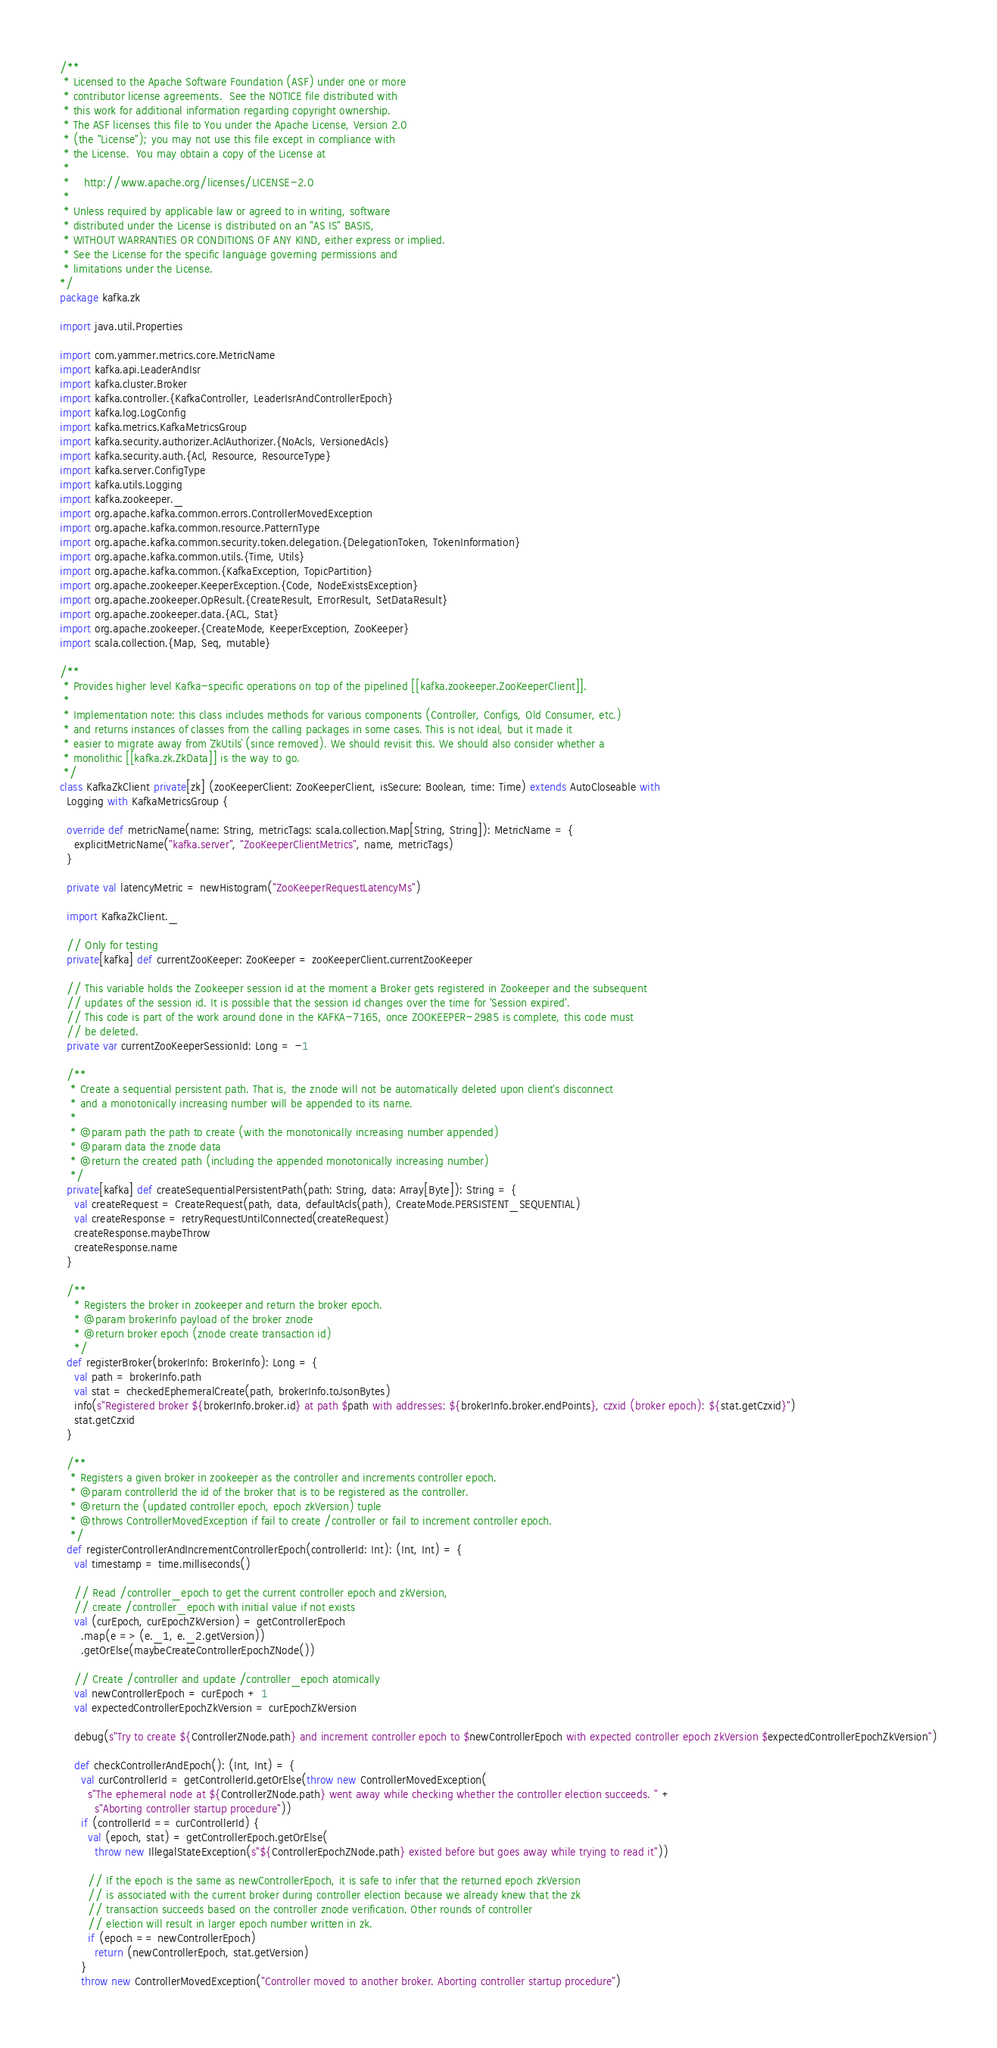Convert code to text. <code><loc_0><loc_0><loc_500><loc_500><_Scala_>/**
 * Licensed to the Apache Software Foundation (ASF) under one or more
 * contributor license agreements.  See the NOTICE file distributed with
 * this work for additional information regarding copyright ownership.
 * The ASF licenses this file to You under the Apache License, Version 2.0
 * (the "License"); you may not use this file except in compliance with
 * the License.  You may obtain a copy of the License at
 *
 *    http://www.apache.org/licenses/LICENSE-2.0
 *
 * Unless required by applicable law or agreed to in writing, software
 * distributed under the License is distributed on an "AS IS" BASIS,
 * WITHOUT WARRANTIES OR CONDITIONS OF ANY KIND, either express or implied.
 * See the License for the specific language governing permissions and
 * limitations under the License.
*/
package kafka.zk

import java.util.Properties

import com.yammer.metrics.core.MetricName
import kafka.api.LeaderAndIsr
import kafka.cluster.Broker
import kafka.controller.{KafkaController, LeaderIsrAndControllerEpoch}
import kafka.log.LogConfig
import kafka.metrics.KafkaMetricsGroup
import kafka.security.authorizer.AclAuthorizer.{NoAcls, VersionedAcls}
import kafka.security.auth.{Acl, Resource, ResourceType}
import kafka.server.ConfigType
import kafka.utils.Logging
import kafka.zookeeper._
import org.apache.kafka.common.errors.ControllerMovedException
import org.apache.kafka.common.resource.PatternType
import org.apache.kafka.common.security.token.delegation.{DelegationToken, TokenInformation}
import org.apache.kafka.common.utils.{Time, Utils}
import org.apache.kafka.common.{KafkaException, TopicPartition}
import org.apache.zookeeper.KeeperException.{Code, NodeExistsException}
import org.apache.zookeeper.OpResult.{CreateResult, ErrorResult, SetDataResult}
import org.apache.zookeeper.data.{ACL, Stat}
import org.apache.zookeeper.{CreateMode, KeeperException, ZooKeeper}
import scala.collection.{Map, Seq, mutable}

/**
 * Provides higher level Kafka-specific operations on top of the pipelined [[kafka.zookeeper.ZooKeeperClient]].
 *
 * Implementation note: this class includes methods for various components (Controller, Configs, Old Consumer, etc.)
 * and returns instances of classes from the calling packages in some cases. This is not ideal, but it made it
 * easier to migrate away from `ZkUtils` (since removed). We should revisit this. We should also consider whether a
 * monolithic [[kafka.zk.ZkData]] is the way to go.
 */
class KafkaZkClient private[zk] (zooKeeperClient: ZooKeeperClient, isSecure: Boolean, time: Time) extends AutoCloseable with
  Logging with KafkaMetricsGroup {

  override def metricName(name: String, metricTags: scala.collection.Map[String, String]): MetricName = {
    explicitMetricName("kafka.server", "ZooKeeperClientMetrics", name, metricTags)
  }

  private val latencyMetric = newHistogram("ZooKeeperRequestLatencyMs")

  import KafkaZkClient._

  // Only for testing
  private[kafka] def currentZooKeeper: ZooKeeper = zooKeeperClient.currentZooKeeper

  // This variable holds the Zookeeper session id at the moment a Broker gets registered in Zookeeper and the subsequent
  // updates of the session id. It is possible that the session id changes over the time for 'Session expired'.
  // This code is part of the work around done in the KAFKA-7165, once ZOOKEEPER-2985 is complete, this code must
  // be deleted.
  private var currentZooKeeperSessionId: Long = -1

  /**
   * Create a sequential persistent path. That is, the znode will not be automatically deleted upon client's disconnect
   * and a monotonically increasing number will be appended to its name.
   *
   * @param path the path to create (with the monotonically increasing number appended)
   * @param data the znode data
   * @return the created path (including the appended monotonically increasing number)
   */
  private[kafka] def createSequentialPersistentPath(path: String, data: Array[Byte]): String = {
    val createRequest = CreateRequest(path, data, defaultAcls(path), CreateMode.PERSISTENT_SEQUENTIAL)
    val createResponse = retryRequestUntilConnected(createRequest)
    createResponse.maybeThrow
    createResponse.name
  }

  /**
    * Registers the broker in zookeeper and return the broker epoch.
    * @param brokerInfo payload of the broker znode
    * @return broker epoch (znode create transaction id)
    */
  def registerBroker(brokerInfo: BrokerInfo): Long = {
    val path = brokerInfo.path
    val stat = checkedEphemeralCreate(path, brokerInfo.toJsonBytes)
    info(s"Registered broker ${brokerInfo.broker.id} at path $path with addresses: ${brokerInfo.broker.endPoints}, czxid (broker epoch): ${stat.getCzxid}")
    stat.getCzxid
  }

  /**
   * Registers a given broker in zookeeper as the controller and increments controller epoch.
   * @param controllerId the id of the broker that is to be registered as the controller.
   * @return the (updated controller epoch, epoch zkVersion) tuple
   * @throws ControllerMovedException if fail to create /controller or fail to increment controller epoch.
   */
  def registerControllerAndIncrementControllerEpoch(controllerId: Int): (Int, Int) = {
    val timestamp = time.milliseconds()

    // Read /controller_epoch to get the current controller epoch and zkVersion,
    // create /controller_epoch with initial value if not exists
    val (curEpoch, curEpochZkVersion) = getControllerEpoch
      .map(e => (e._1, e._2.getVersion))
      .getOrElse(maybeCreateControllerEpochZNode())

    // Create /controller and update /controller_epoch atomically
    val newControllerEpoch = curEpoch + 1
    val expectedControllerEpochZkVersion = curEpochZkVersion

    debug(s"Try to create ${ControllerZNode.path} and increment controller epoch to $newControllerEpoch with expected controller epoch zkVersion $expectedControllerEpochZkVersion")

    def checkControllerAndEpoch(): (Int, Int) = {
      val curControllerId = getControllerId.getOrElse(throw new ControllerMovedException(
        s"The ephemeral node at ${ControllerZNode.path} went away while checking whether the controller election succeeds. " +
          s"Aborting controller startup procedure"))
      if (controllerId == curControllerId) {
        val (epoch, stat) = getControllerEpoch.getOrElse(
          throw new IllegalStateException(s"${ControllerEpochZNode.path} existed before but goes away while trying to read it"))

        // If the epoch is the same as newControllerEpoch, it is safe to infer that the returned epoch zkVersion
        // is associated with the current broker during controller election because we already knew that the zk
        // transaction succeeds based on the controller znode verification. Other rounds of controller
        // election will result in larger epoch number written in zk.
        if (epoch == newControllerEpoch)
          return (newControllerEpoch, stat.getVersion)
      }
      throw new ControllerMovedException("Controller moved to another broker. Aborting controller startup procedure")</code> 